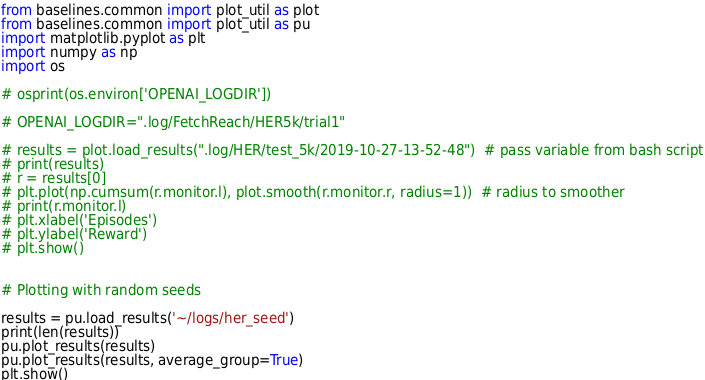<code> <loc_0><loc_0><loc_500><loc_500><_Python_>from baselines.common import plot_util as plot
from baselines.common import plot_util as pu
import matplotlib.pyplot as plt
import numpy as np
import os

# osprint(os.environ['OPENAI_LOGDIR'])

# OPENAI_LOGDIR=".log/FetchReach/HER5k/trial1"

# results = plot.load_results(".log/HER/test_5k/2019-10-27-13-52-48")  # pass variable from bash script
# print(results)
# r = results[0]
# plt.plot(np.cumsum(r.monitor.l), plot.smooth(r.monitor.r, radius=1))  # radius to smoother
# print(r.monitor.l)
# plt.xlabel('Episodes')
# plt.ylabel('Reward')
# plt.show()


# Plotting with random seeds

results = pu.load_results('~/logs/her_seed')
print(len(results))
pu.plot_results(results)
pu.plot_results(results, average_group=True)
plt.show()
</code> 